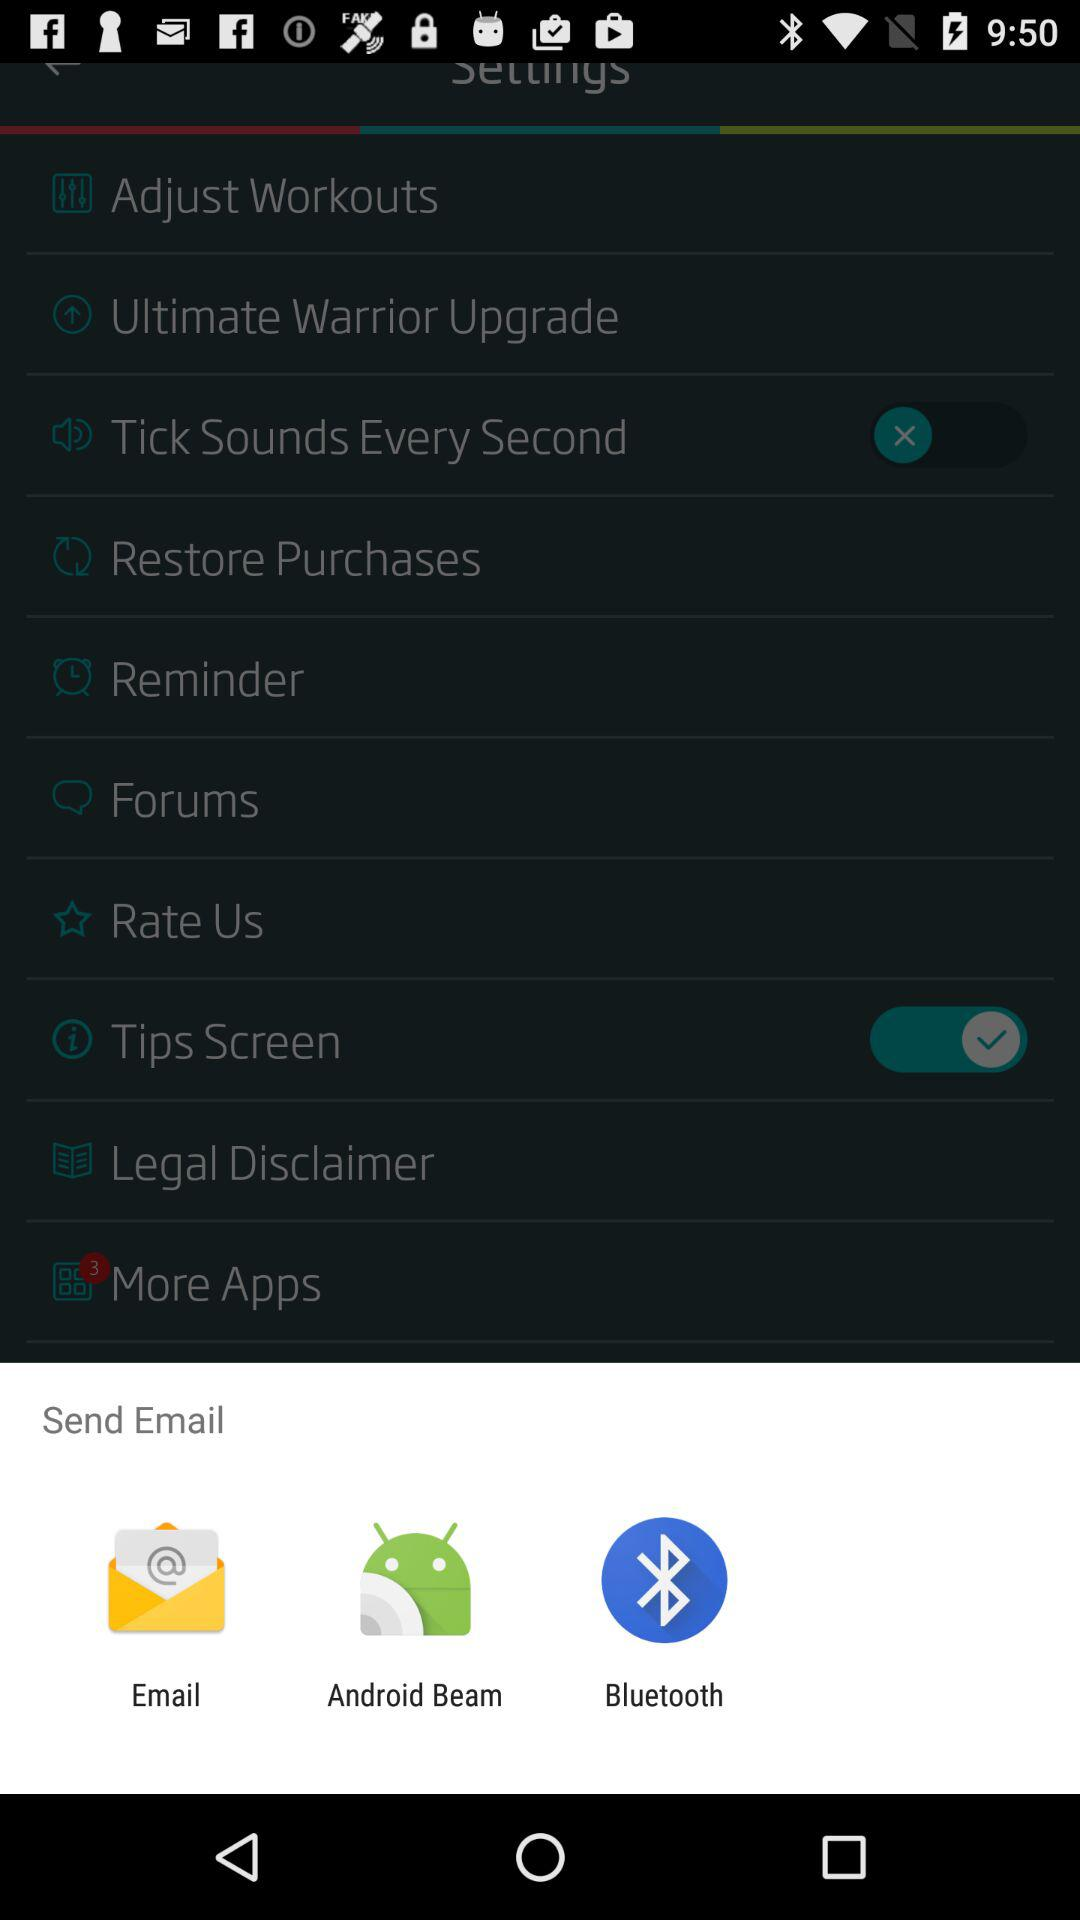How many stars does the application have?
When the provided information is insufficient, respond with <no answer>. <no answer> 